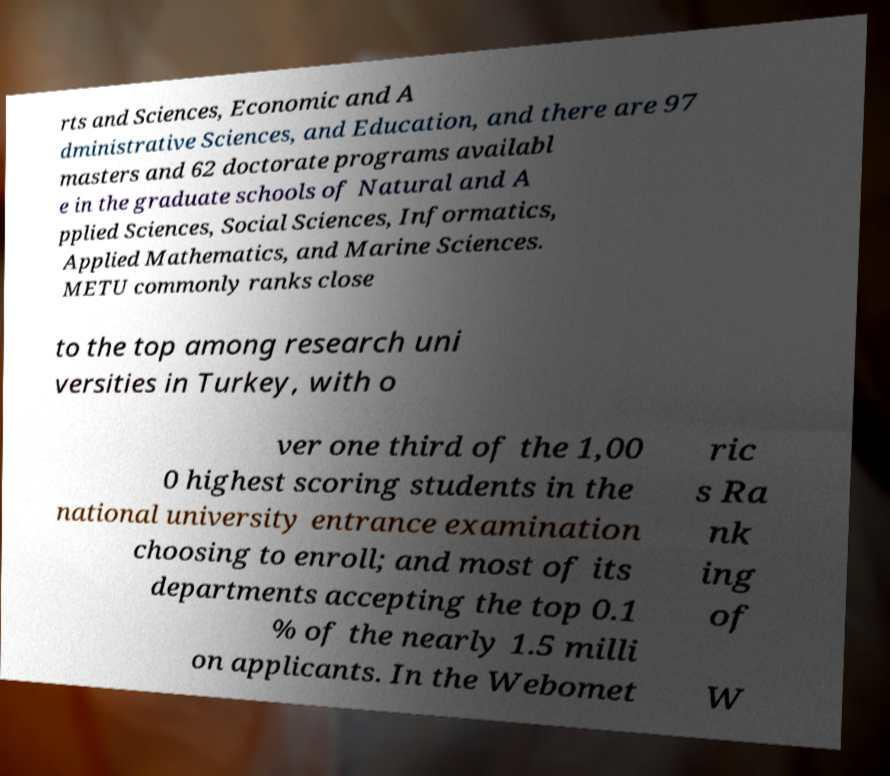Could you assist in decoding the text presented in this image and type it out clearly? rts and Sciences, Economic and A dministrative Sciences, and Education, and there are 97 masters and 62 doctorate programs availabl e in the graduate schools of Natural and A pplied Sciences, Social Sciences, Informatics, Applied Mathematics, and Marine Sciences. METU commonly ranks close to the top among research uni versities in Turkey, with o ver one third of the 1,00 0 highest scoring students in the national university entrance examination choosing to enroll; and most of its departments accepting the top 0.1 % of the nearly 1.5 milli on applicants. In the Webomet ric s Ra nk ing of W 